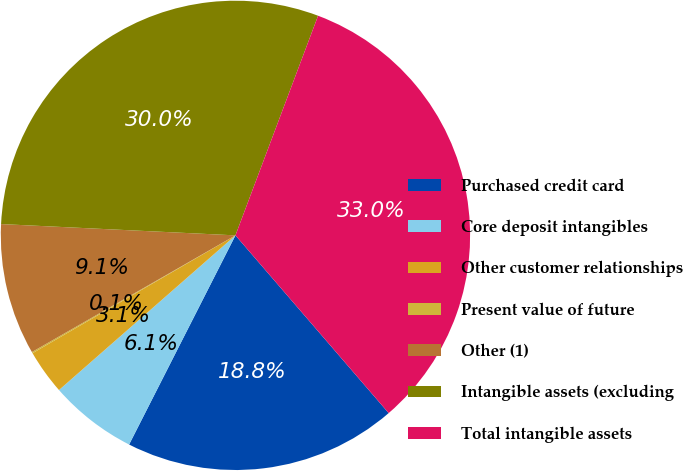Convert chart. <chart><loc_0><loc_0><loc_500><loc_500><pie_chart><fcel>Purchased credit card<fcel>Core deposit intangibles<fcel>Other customer relationships<fcel>Present value of future<fcel>Other (1)<fcel>Intangible assets (excluding<fcel>Total intangible assets<nl><fcel>18.81%<fcel>6.06%<fcel>3.08%<fcel>0.09%<fcel>9.05%<fcel>29.96%<fcel>32.95%<nl></chart> 